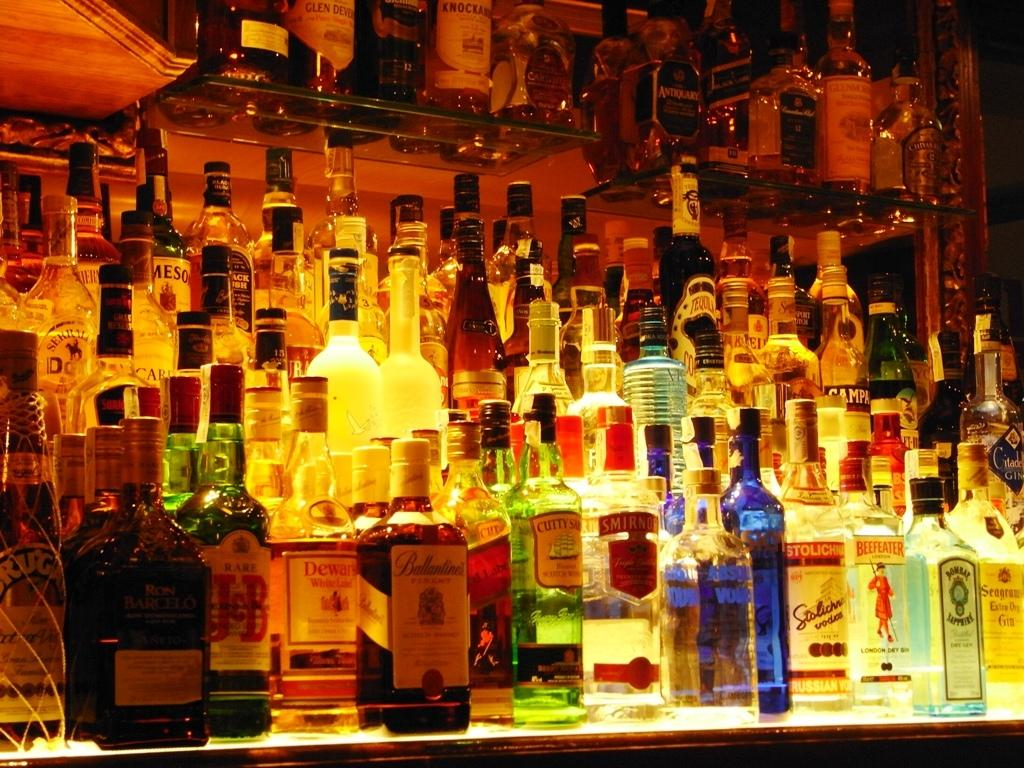What is the main subject of the image? The main subject of the image is many wine bottles. Where are the wine bottles located in the image? The wine bottles are placed on a table. How does the ice form on the wine bottles in the image? There is no ice present on the wine bottles in the image. 